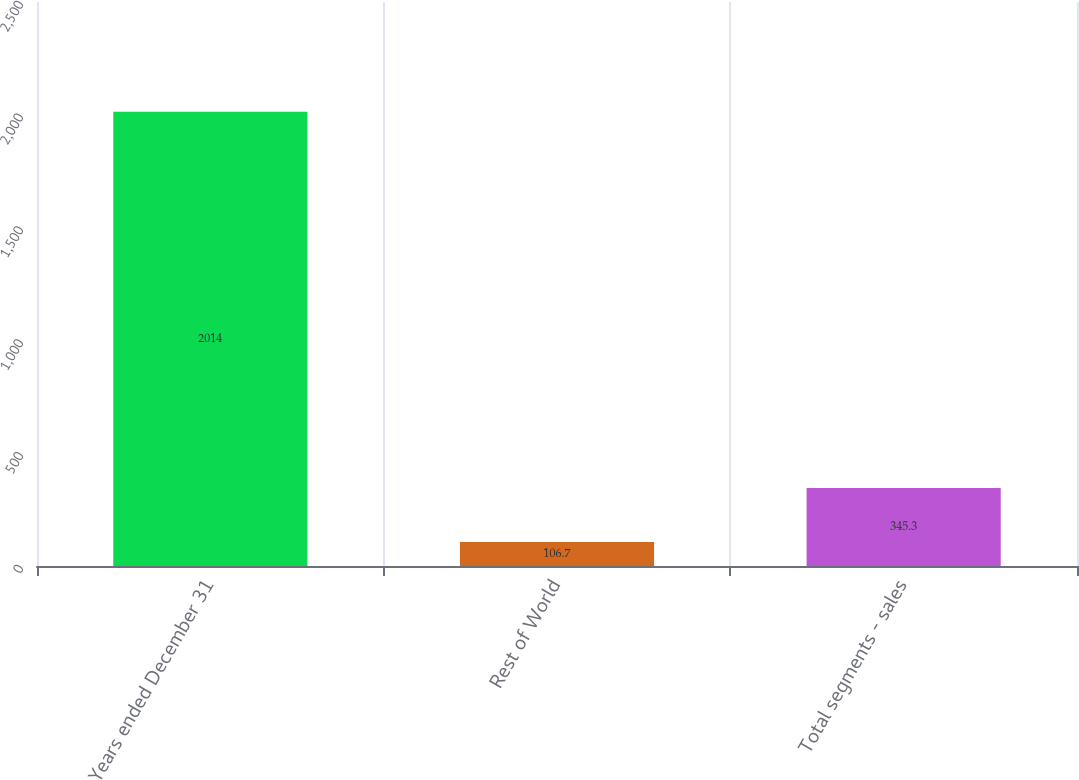<chart> <loc_0><loc_0><loc_500><loc_500><bar_chart><fcel>Years ended December 31<fcel>Rest of World<fcel>Total segments - sales<nl><fcel>2014<fcel>106.7<fcel>345.3<nl></chart> 